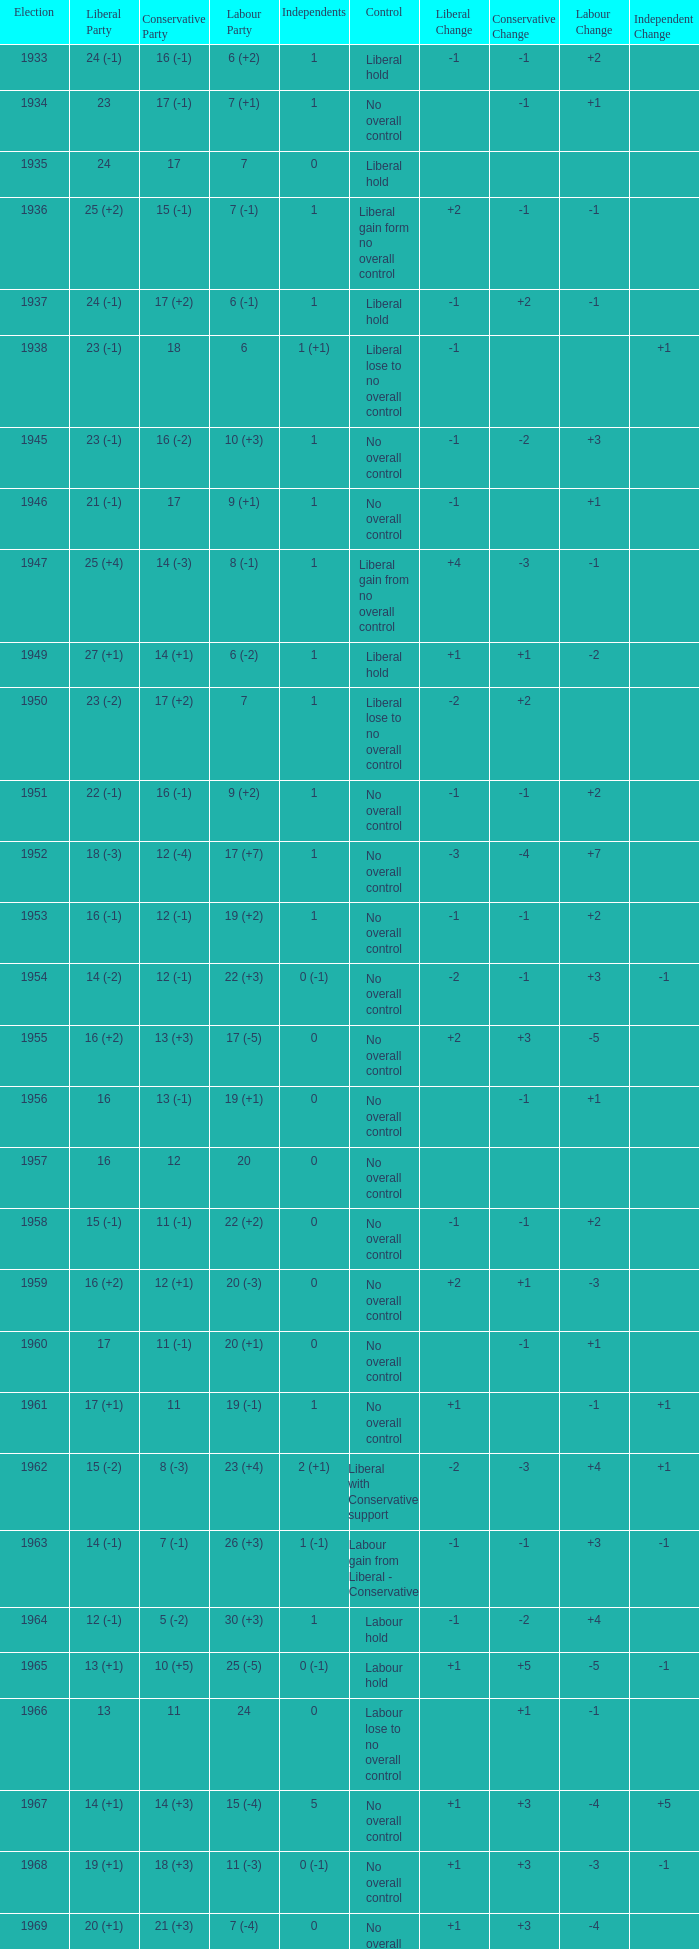Who was in control the year that Labour Party won 12 (+6) seats? No overall control (1 vacancy). 